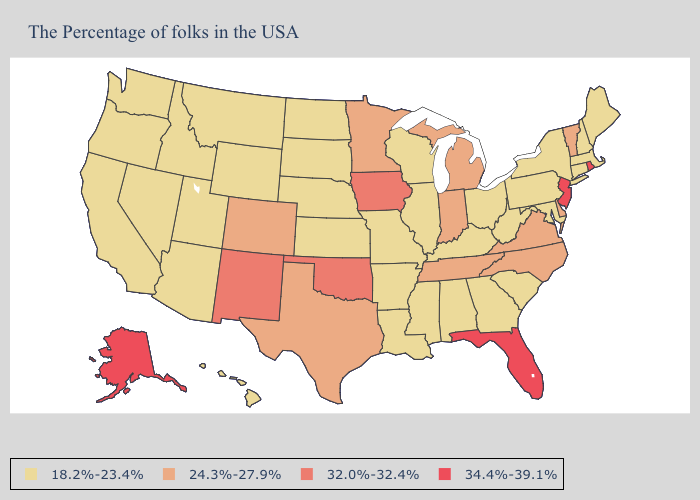Among the states that border Oklahoma , which have the lowest value?
Give a very brief answer. Missouri, Arkansas, Kansas. What is the highest value in the South ?
Quick response, please. 34.4%-39.1%. Which states hav the highest value in the South?
Answer briefly. Florida. What is the value of Oregon?
Keep it brief. 18.2%-23.4%. How many symbols are there in the legend?
Quick response, please. 4. Name the states that have a value in the range 32.0%-32.4%?
Write a very short answer. Iowa, Oklahoma, New Mexico. Which states have the highest value in the USA?
Keep it brief. Rhode Island, New Jersey, Florida, Alaska. What is the value of Utah?
Give a very brief answer. 18.2%-23.4%. Name the states that have a value in the range 32.0%-32.4%?
Quick response, please. Iowa, Oklahoma, New Mexico. Which states hav the highest value in the MidWest?
Quick response, please. Iowa. Name the states that have a value in the range 34.4%-39.1%?
Keep it brief. Rhode Island, New Jersey, Florida, Alaska. What is the value of North Carolina?
Keep it brief. 24.3%-27.9%. Does Rhode Island have the same value as California?
Keep it brief. No. Name the states that have a value in the range 34.4%-39.1%?
Concise answer only. Rhode Island, New Jersey, Florida, Alaska. 